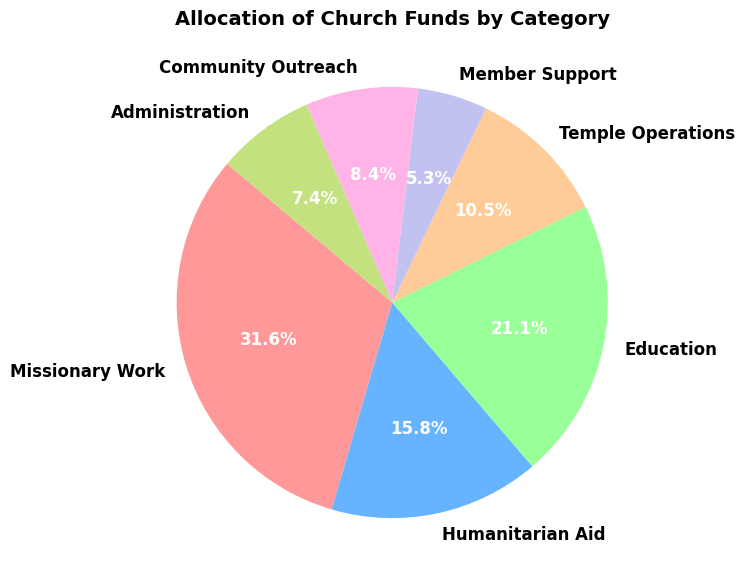Which category has the highest allocation of church funds? The figure labels each category and the amount of money allocated to it. By scanning the amounts, it is clear that "Missionary Work" has the highest allocation with $30,000,000.
Answer: Missionary Work Which two categories combined account for more than 50% of the total allocation? To determine this, sum the highest two allocations and compare it to 50% of the total allocation. Missionary Work ($30,000,000) and Education ($20,000,000) combined is $50,000,000. The total allocation is $95,000,000, so 50% of the total is $47,500,000. Since $50,000,000 > $47,500,000, these two categories account for more than 50%.
Answer: Missionary Work and Education What is the difference in allocation between Education and Humanitarian Aid? Education is allocated $20,000,000 and Humanitarian Aid is allocated $15,000,000. The difference between these amounts is $20,000,000 - $15,000,000.
Answer: $5,000,000 What percentage of the total allocation is given to Temple Operations? The total allocation is $95,000,000 and Temple Operations receives $10,000,000. The percentage is calculated by (10,000,000 / 95,000,000) * 100.
Answer: 10.5% Which categories collectively form the smallest third of the total allocation? To find the smallest third, calculate the total allocation and divide it by three: $95,000,000 / 3 ≈ $31,666,667. The categories with the smallest allocations are Member Support ($5,000,000), Community Outreach ($8,000,000), and Administration ($7,000,000), summing to $20,000,000. As this sum is less than $31,666,667, it forms the smallest third.
Answer: Member Support, Community Outreach, and Administration How does the allocation for Member Support compare to Community Outreach? Member Support is allocated $5,000,000 while Community Outreach receives $8,000,000. Therefore, Community Outreach receives more funds than Member Support.
Answer: Community Outreach receives more How many categories have allocations less than $10,000,000? Review the allocations for each category. Member Support ($5,000,000), Community Outreach ($8,000,000), and Administration ($7,000,000) are all less than $10,000,000.
Answer: 3 What is the average allocation per category? Sum all allocations and divide by the number of categories. Total is $95,000,000 and there are 7 categories. Average is $95,000,000 / 7.
Answer: $13,571,429 What would the allocation percentage for Administration be if it increased by $3,000,000? Current Administration allocation is $7,000,000. With an extra $3,000,000, it becomes $10,000,000. New total allocation: $95,000,000 + $3,000,000 = $98,000,000. New percentage: ($10,000,000 / $98,000,000) * 100.
Answer: 10.2% What is the proportion of Missionary Work to the total allocation? Missionary Work is allocated $30,000,000. Total allocation is $95,000,000. Proportion is $30,000,000 / $95,000,000.
Answer: 0.316 